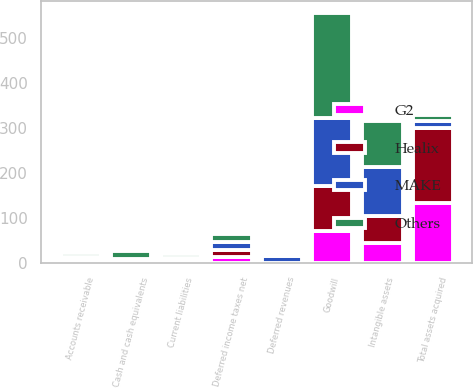<chart> <loc_0><loc_0><loc_500><loc_500><stacked_bar_chart><ecel><fcel>Cash and cash equivalents<fcel>Accounts receivable<fcel>Intangible assets<fcel>Goodwill<fcel>Total assets acquired<fcel>Current liabilities<fcel>Deferred revenues<fcel>Deferred income taxes net<nl><fcel>MAKE<fcel>7.7<fcel>8.3<fcel>109.6<fcel>150.1<fcel>14.1<fcel>6.4<fcel>14.7<fcel>18.6<nl><fcel>Healix<fcel>1.1<fcel>2.9<fcel>59<fcel>99.5<fcel>167.7<fcel>1.1<fcel>0.3<fcel>14.6<nl><fcel>Others<fcel>16<fcel>7.5<fcel>102.4<fcel>233.9<fcel>14.1<fcel>9.9<fcel>4<fcel>18.6<nl><fcel>G2<fcel>0.9<fcel>2.5<fcel>45.3<fcel>72<fcel>133.1<fcel>3.4<fcel>0.4<fcel>13.6<nl></chart> 